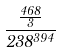Convert formula to latex. <formula><loc_0><loc_0><loc_500><loc_500>\frac { \frac { 4 6 8 } { 3 } } { 2 3 8 ^ { 3 9 4 } }</formula> 